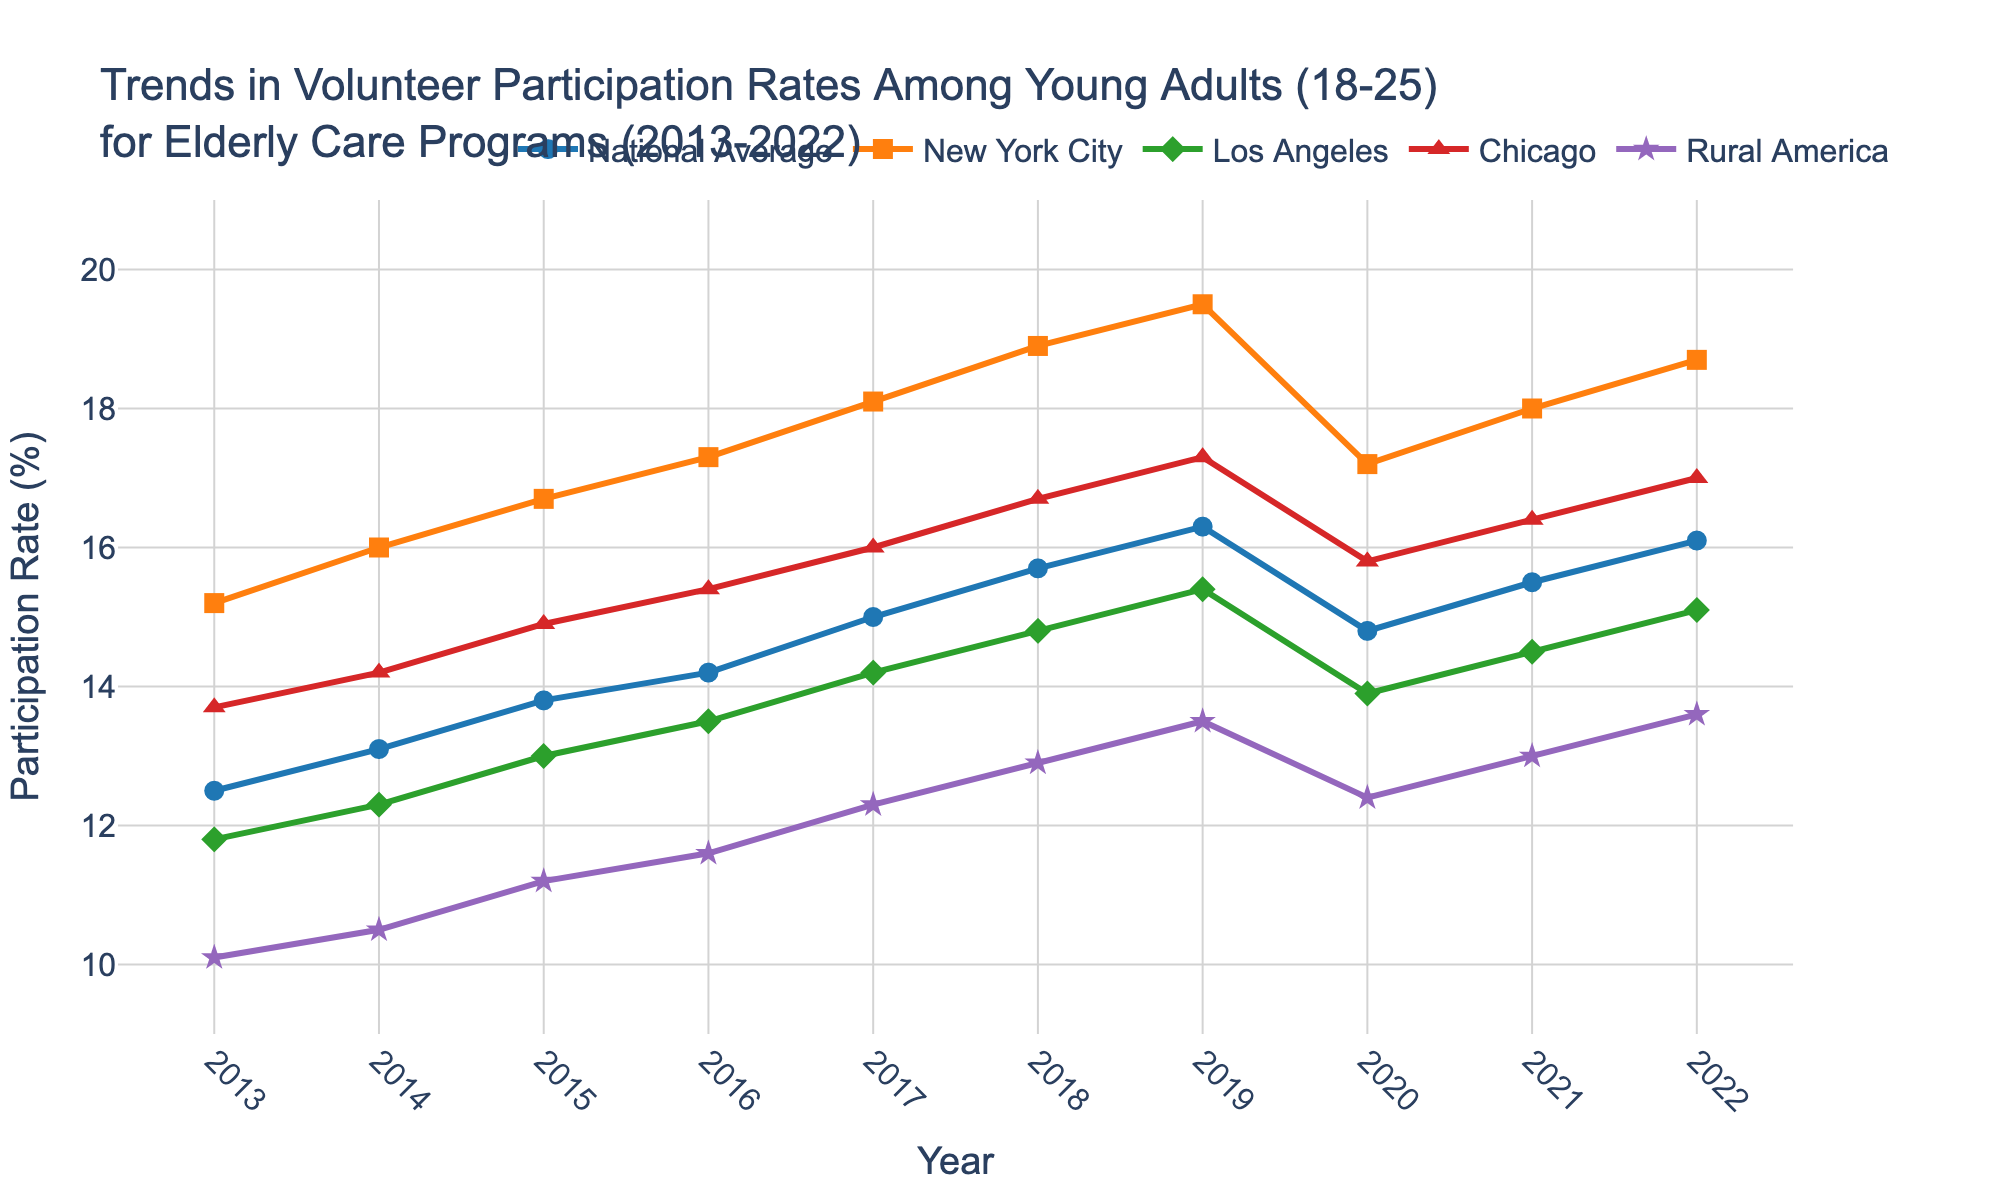Which city had the highest volunteer participation rate in 2022? To determine this, we visually inspect the line chart for the year 2022 and look for the highest data point among the cities. New York City has the highest participant rate at around 18.7%.
Answer: New York City Which year saw the largest decline in the national average volunteer participation rate? To find the largest decline, we look for the biggest drop between consecutive years. From 2019 to 2020, there is a drop from 16.3% to 14.8%.
Answer: 2020 How did the participation rates in Rural America change from 2013 to 2020? First, note the participation rate for Rural America in 2013 (10.1%) and in 2020 (12.4%). To find the change, subtract the 2013 rate from the 2020 rate: 12.4% - 10.1% = 2.3%.
Answer: Increased by 2.3% Between Los Angeles and Chicago, which city had a higher volunteer rate in 2015, and what was the difference? Look at both points for 2015 on the chart. Los Angeles is at 13.0%, and Chicago is at 14.9%. Chicago is higher. The difference is 14.9% - 13.0% = 1.9%.
Answer: Chicago, 1.9% What's the average participation rate across all areas in 2017? Calculate the average by summing the participation rates for all areas in 2017 and dividing by the number of areas. (15.0% + 18.1% + 14.2% + 16.0% + 12.3%) / 5 = 15.12%.
Answer: 15.12% In which year did New York City see the highest increase in participation rate compared to the previous year? Calculate year-over-year increases. The largest increase is from 14.9% in 2016 to 18.1% in 2017, where the increase is 1.2%.
Answer: 2017 What is the trend for the national average from 2013 to 2019, and what does it indicate? Examine the year-by-year data points for the national average from 2013 to 2019. The values progressively increase from 12.5% in 2013 to 16.3% in 2019. This indicates a consistent upward trend.
Answer: Upward trend Compare the participation rates for Chicago and Rural America in the year 2018. Which had a higher rate? Locate the data points for Chicago and Rural America in 2018. Chicago’s rate is at 16.7%, and Rural America’s rate is at 12.9%. Chicago has a higher rate.
Answer: Chicago What is the difference between the highest and lowest participation rates in 2022? Identify the highest and lowest points for 2022 among all regions. The highest is New York City at 18.7%, and the lowest is Rural America at 13.6%. The difference is 18.7% - 13.6% = 5.1%.
Answer: 5.1% 